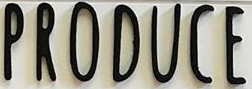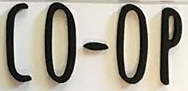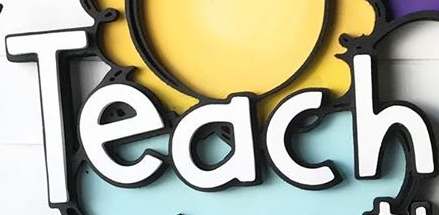What text is displayed in these images sequentially, separated by a semicolon? PRODUCE; CO-OP; Teach 